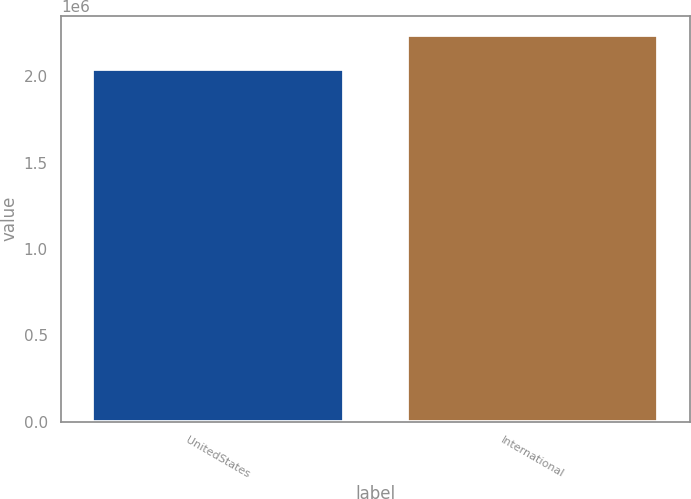Convert chart. <chart><loc_0><loc_0><loc_500><loc_500><bar_chart><fcel>UnitedStates<fcel>International<nl><fcel>2.04048e+06<fcel>2.23673e+06<nl></chart> 